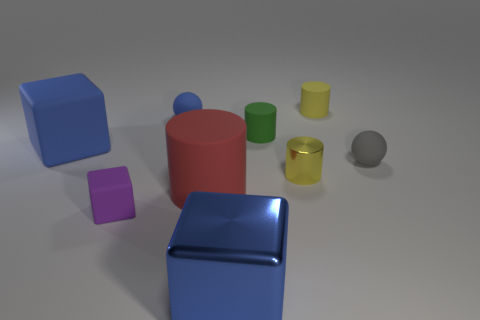Subtract all red cylinders. How many cylinders are left? 3 Subtract all brown cylinders. Subtract all green blocks. How many cylinders are left? 4 Add 1 big green blocks. How many objects exist? 10 Subtract all spheres. How many objects are left? 7 Add 1 cyan metal blocks. How many cyan metal blocks exist? 1 Subtract 0 green blocks. How many objects are left? 9 Subtract all large green cylinders. Subtract all gray objects. How many objects are left? 8 Add 7 rubber spheres. How many rubber spheres are left? 9 